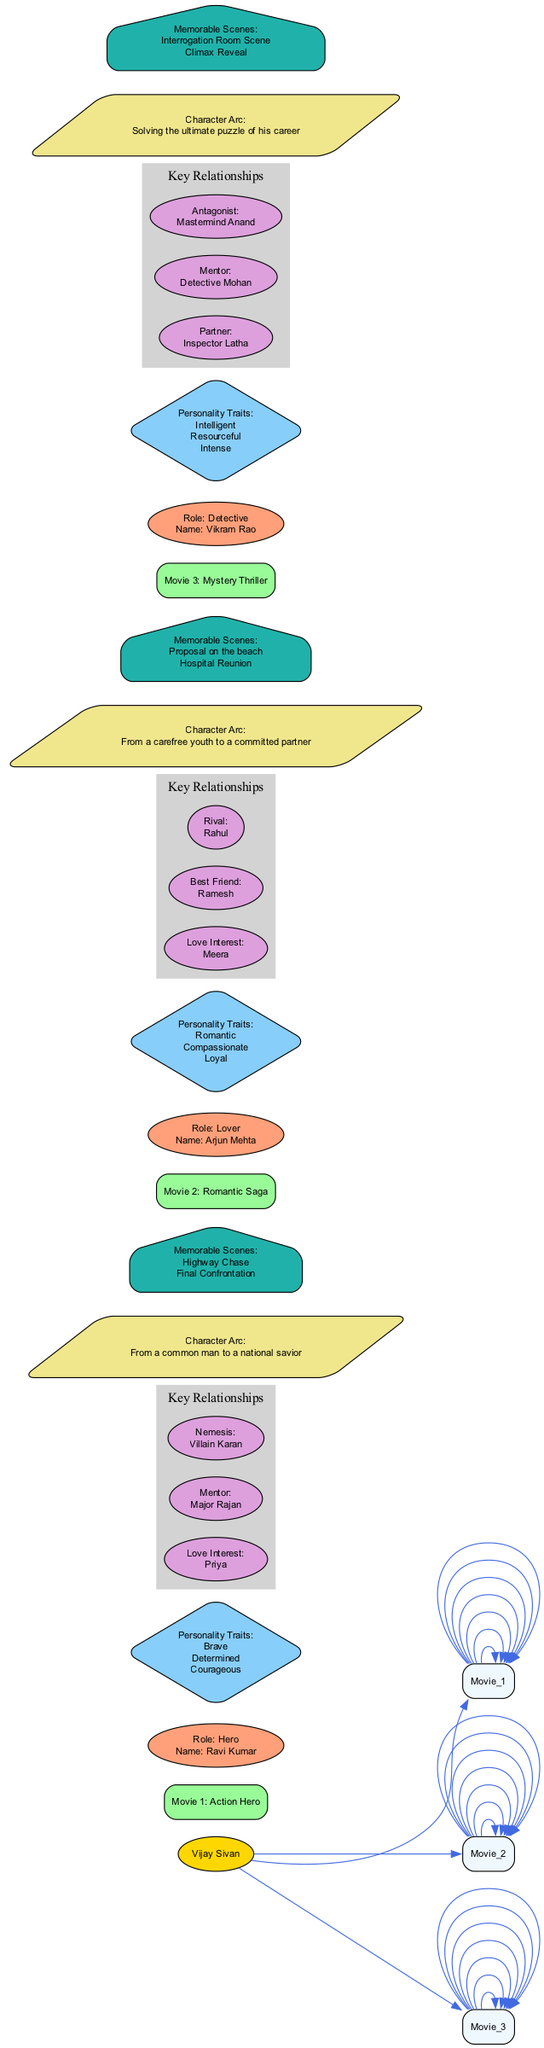What is the role of the character in "Movie 1: Action Hero"? The diagram indicates that the role of the character in "Movie 1: Action Hero" is "Hero". This information is directly specified in the node related to the movie.
Answer: Hero What character trait is associated with Arjun Mehta in "Movie 2: Romantic Saga"? From the diagram, it can be seen that "Romantic" is one of the personality traits listed for Arjun Mehta in "Movie 2: Romantic Saga". This trait is presented in the respective traits node for this movie.
Answer: Romantic Who is the love interest of Ravi Kumar in "Movie 1: Action Hero"? The diagram shows that the love interest of Ravi Kumar in "Movie 1: Action Hero" is "Priya". This is clearly stated in the key relationships section for this character.
Answer: Priya How many memorable scenes are listed for "Movie 3: Mystery Thriller"? The diagram lists two memorable scenes for "Movie 3: Mystery Thriller": "Interrogation Room Scene" and "Climax Reveal". To find the count, I can simply enumerate these scenes.
Answer: 2 What is the character arc of Vikram Rao in "Movie 3: Mystery Thriller"? In the diagram, the character arc of Vikram Rao is described as "Solving the ultimate puzzle of his career". This statement is in the section that details his character arc.
Answer: Solving the ultimate puzzle of his career Which character has "Determined" as a personality trait? The diagram reveals that "Determined" is one of the personality traits of Ravi Kumar in "Movie 1: Action Hero". By looking at the traits node for this movie, this information can be directly gathered.
Answer: Ravi Kumar Who is the antagonist for Vikram Rao in "Movie 3: Mystery Thriller"? The diagram notes that Vikram Rao's antagonist in "Movie 3: Mystery Thriller" is "Mastermind Anand". This information can be found in the Key Relationships section of the character analysis.
Answer: Mastermind Anand What type of diagram is this? This diagram is classified as a "Concept map". The structure and organization of the information presented indicate that it serves to connect various concepts related to character analysis in Vijay Sivan's movies.
Answer: Concept map 